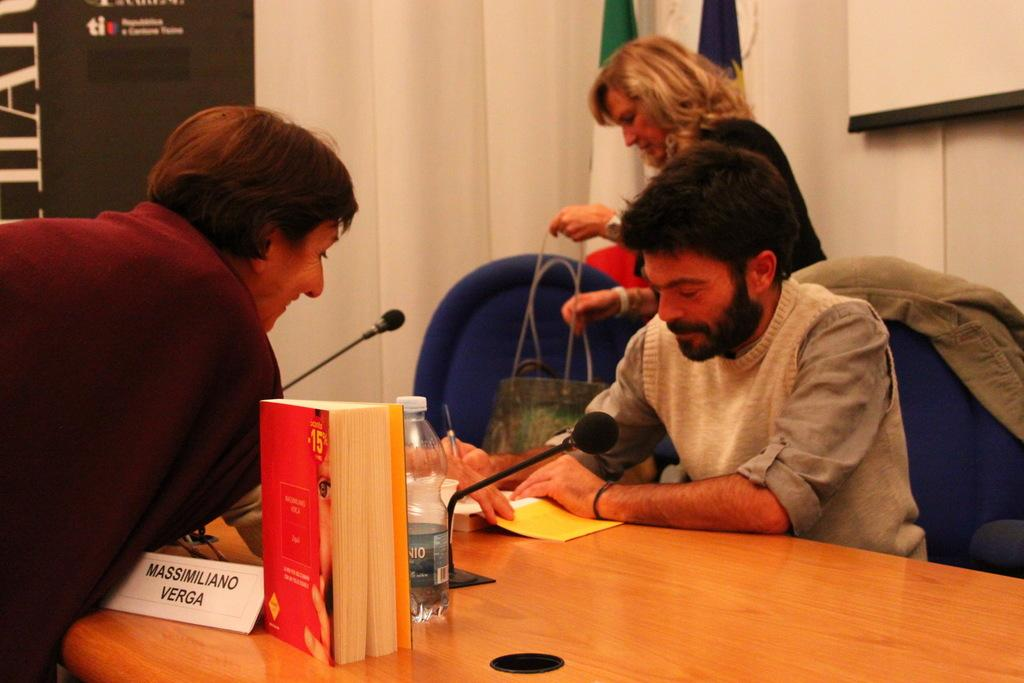<image>
Relay a brief, clear account of the picture shown. Author Massimiliano Verga signs a book during a book signing event. 